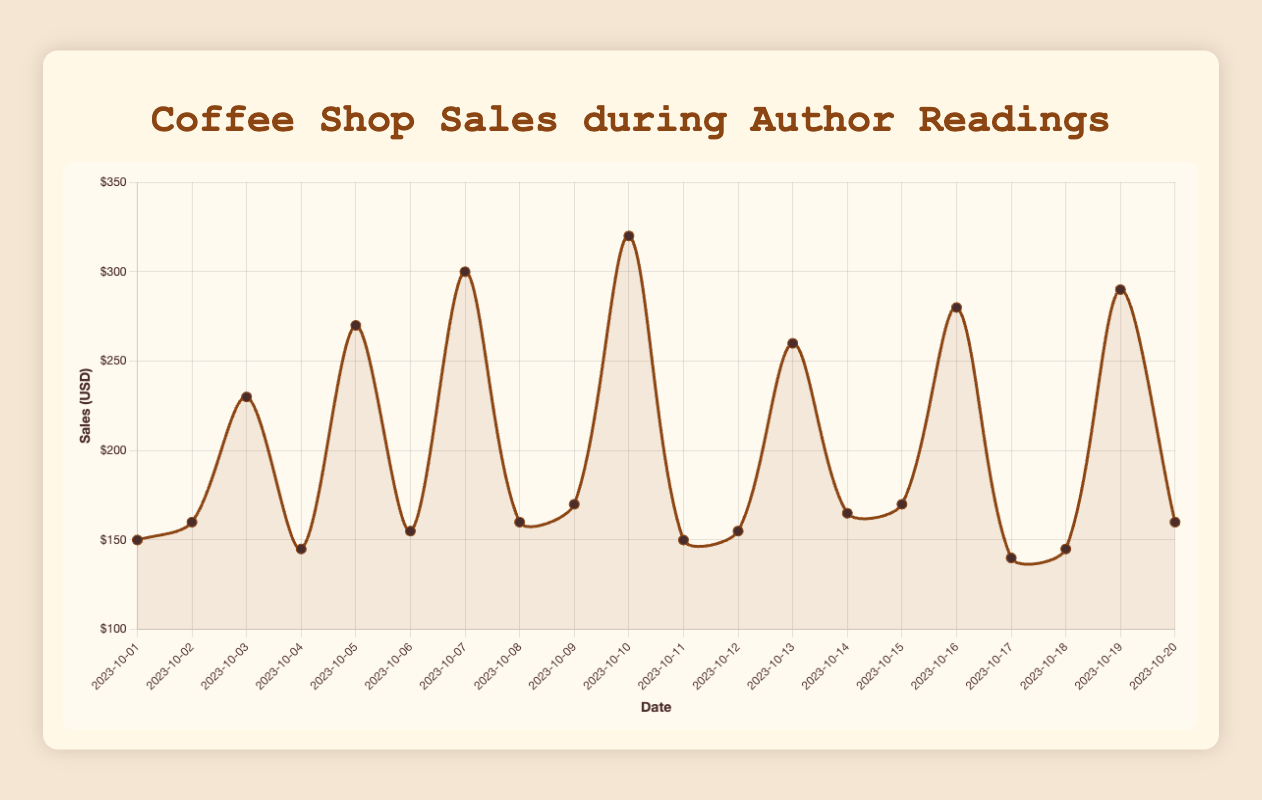What is the average sales on days with author readings? First, identify the sales on days with author readings: (230, 270, 300, 320, 260, 280, 290). Sum these values: 230 + 270 + 300 + 320 + 260 + 280 + 290 = 1950. Divide by the number of days with readings (7): 1950 / 7 = 278.57
Answer: 278.57 On which day did the coffee shop have the highest sales? Look for the highest point in the line plot and cross-reference with the date label. The highest sales value is 320, which occurred on 2023-10-10.
Answer: 2023-10-10 How do the sales on 2023-10-01 compare to the sales on 2023-10-07? Check the sales values for both dates: 2023-10-01 (150) and 2023-10-07 (300). The sales on 2023-10-07 are significantly higher (by 150 units).
Answer: 300 > 150 What was the difference in sales between the highest and lowest sales days? The highest sales were 320, and the lowest were 140. Calculate the difference: 320 - 140 = 180.
Answer: 180 How much did sales increase from 2023-10-02 to 2023-10-03 when Mary Karr had a reading? Subtract sales on 2023-10-02 (160) from sales on 2023-10-03 (230): 230 - 160 = 70.
Answer: 70 Which author reading brought in the highest sales? Compare sales on days with author readings. The highest sales occurred on 2023-10-10 during Stephen King's reading with 320 sales.
Answer: Stephen King During author readings, what is the median sales figure? Arrange sales from days with author readings in ascending order: (230, 260, 270, 280, 290, 300, 320). The median is the middle value of this ordered list, which is 280.
Answer: 280 What was the sales trend immediately following an author reading day? After each reading (e.g., 2023-10-03), check the sales on the next day (e.g., 2023-10-04). Notice sales tend to drop (e.g., from 230 on 2023-10-03 to 145 on 2023-10-04). This trend repeats each time.
Answer: Drop in sales How do the colors and line styles in the plot help to interpret the data? The line color is used consistently to represent sales, making it easy to distinguish data points. Points corresponding to sales on author reading days are often more pronounced due to higher values. The background shading highlights the smoothness and pattern of sales changes over time.
Answer: Enhances readability 